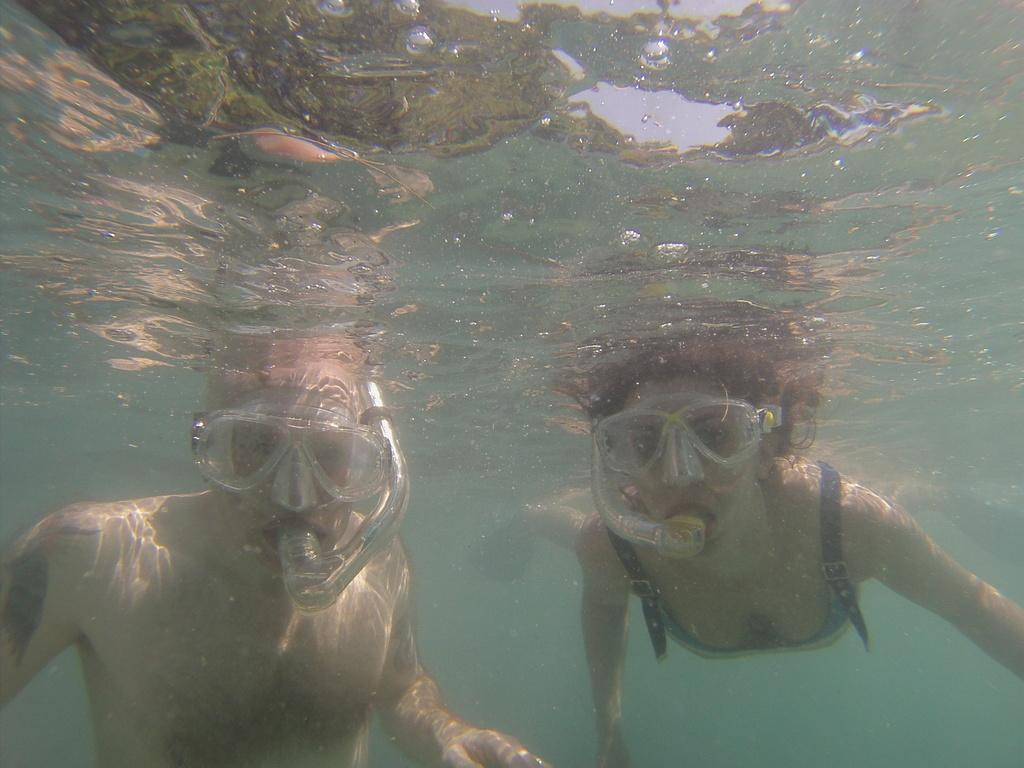Who is present in the image? There is a man and a woman in the image. What are the man and the woman doing in the image? Both the man and the woman are underwater. What equipment are they using for breathing underwater? The man and the woman are wearing snorkels. What does the coach regret about the man and woman's performance in the image? There is no coach present in the image, and therefore no performance to evaluate or regret. 